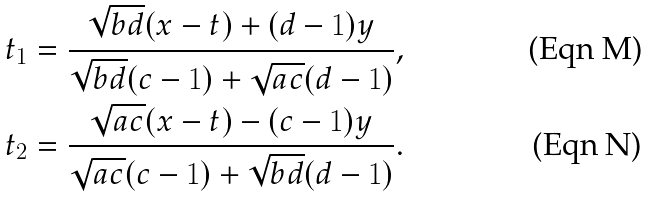Convert formula to latex. <formula><loc_0><loc_0><loc_500><loc_500>t _ { 1 } & = \frac { \sqrt { b d } ( x - t ) + ( d - 1 ) y } { \sqrt { b d } ( c - 1 ) + \sqrt { a c } ( d - 1 ) } , \\ t _ { 2 } & = \frac { \sqrt { a c } ( x - t ) - ( c - 1 ) y } { \sqrt { a c } ( c - 1 ) + \sqrt { b d } ( d - 1 ) } .</formula> 